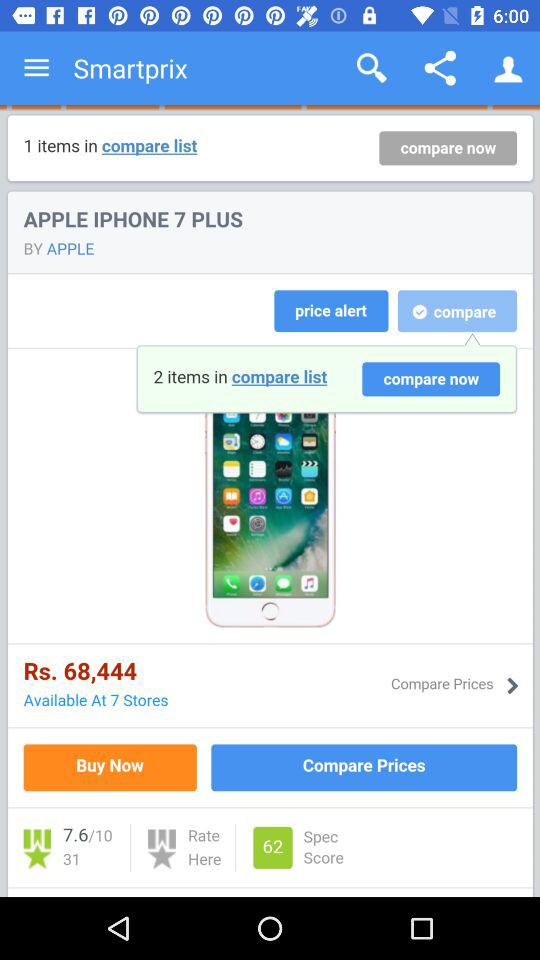How many items are in the "compare list"? There are 2 items. 